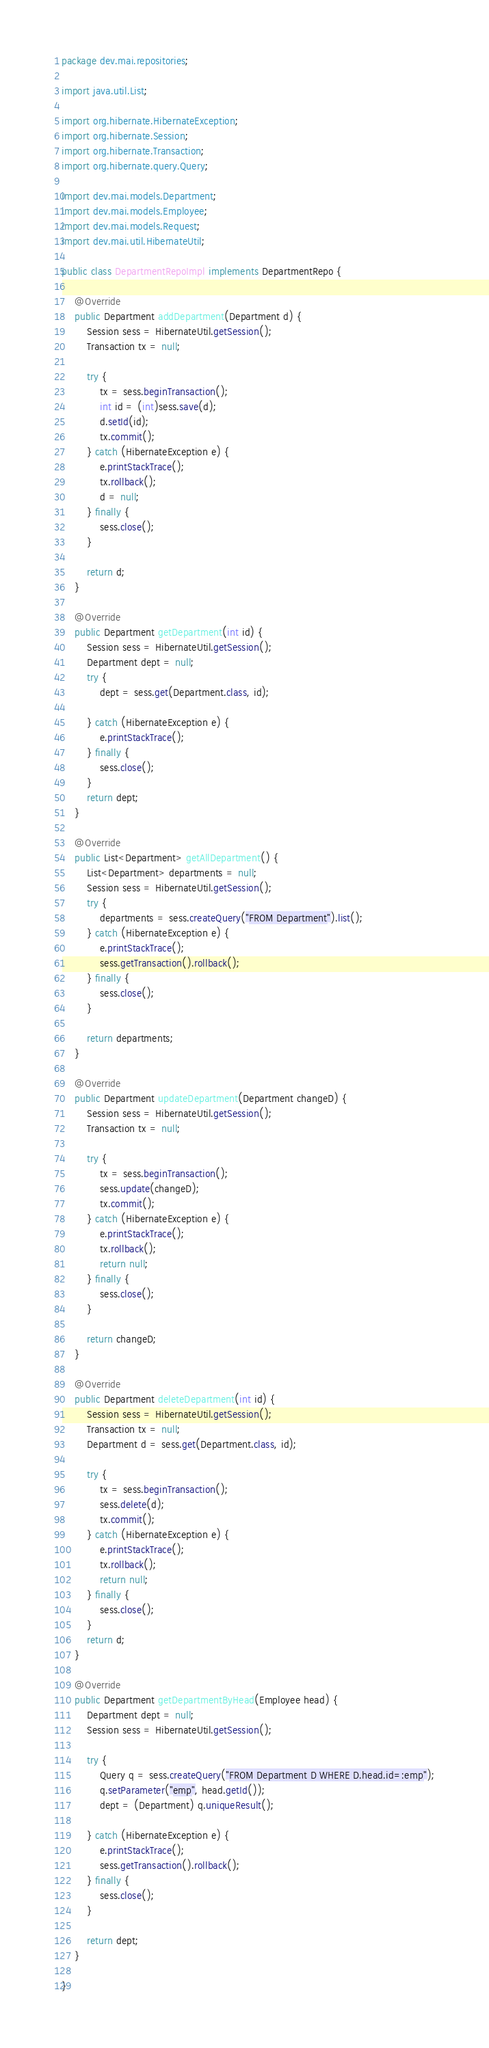<code> <loc_0><loc_0><loc_500><loc_500><_Java_>package dev.mai.repositories;

import java.util.List;

import org.hibernate.HibernateException;
import org.hibernate.Session;
import org.hibernate.Transaction;
import org.hibernate.query.Query;

import dev.mai.models.Department;
import dev.mai.models.Employee;
import dev.mai.models.Request;
import dev.mai.util.HibernateUtil;

public class DepartmentRepoImpl implements DepartmentRepo {

	@Override
	public Department addDepartment(Department d) {
		Session sess = HibernateUtil.getSession();
		Transaction tx = null;

		try {
			tx = sess.beginTransaction();
			int id = (int)sess.save(d);
			d.setId(id);
			tx.commit();
		} catch (HibernateException e) {
			e.printStackTrace();
			tx.rollback();
			d = null;
		} finally {
			sess.close();
		}
		
		return d;
	}

	@Override
	public Department getDepartment(int id) {
		Session sess = HibernateUtil.getSession();
		Department dept = null;
		try {
			dept = sess.get(Department.class, id);
			
		} catch (HibernateException e) {
			e.printStackTrace();
		} finally {
			sess.close();
		}
		return dept;
	}

	@Override
	public List<Department> getAllDepartment() {
		List<Department> departments = null; 
		Session sess = HibernateUtil.getSession();
		try {
			departments = sess.createQuery("FROM Department").list();
		} catch (HibernateException e) {
			e.printStackTrace();
			sess.getTransaction().rollback(); 
		} finally {
			sess.close();
		}

		return departments;
	}

	@Override
	public Department updateDepartment(Department changeD) {
		Session sess = HibernateUtil.getSession();
		Transaction tx = null;
		
		try {
			tx = sess.beginTransaction();
			sess.update(changeD);
			tx.commit();
		} catch (HibernateException e) {
			e.printStackTrace();
			tx.rollback();
			return null;
		} finally {
			sess.close();
		}
		
		return changeD;
	}

	@Override
	public Department deleteDepartment(int id) {
		Session sess = HibernateUtil.getSession();
		Transaction tx = null;
		Department d = sess.get(Department.class, id);
		
		try {
			tx = sess.beginTransaction();
			sess.delete(d);
			tx.commit();
		} catch (HibernateException e) {
			e.printStackTrace();
			tx.rollback();
			return null;
		} finally {
			sess.close();
		}
		return d;
	}

	@Override
	public Department getDepartmentByHead(Employee head) {
		Department dept = null;
		Session sess = HibernateUtil.getSession();
		
		try {
			Query q = sess.createQuery("FROM Department D WHERE D.head.id=:emp");
			q.setParameter("emp", head.getId());
			dept = (Department) q.uniqueResult();
	
		} catch (HibernateException e) {
			e.printStackTrace();
			sess.getTransaction().rollback();
		} finally {
			sess.close();
		}
		
		return dept;
	}

}
</code> 